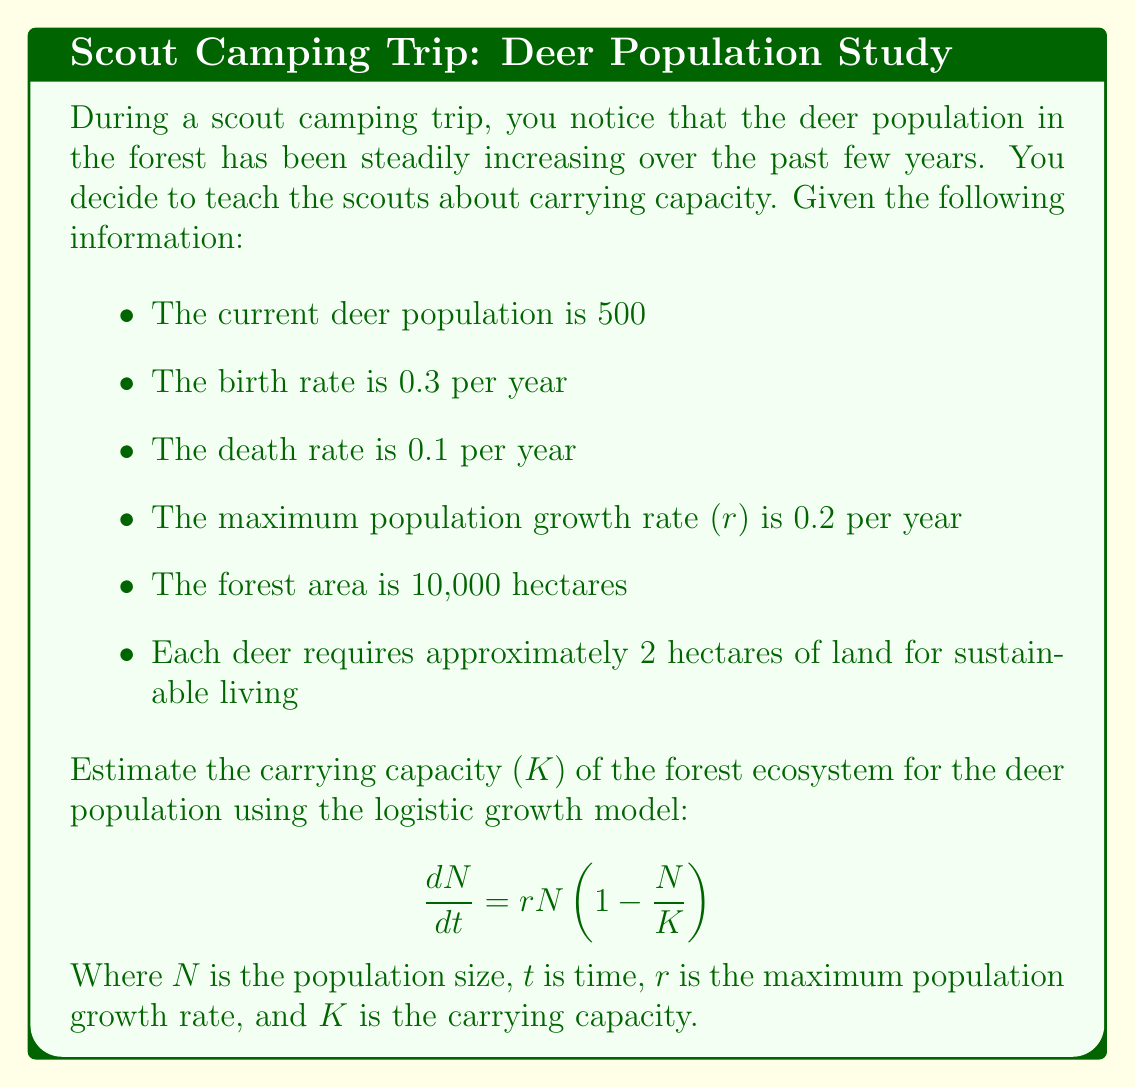Give your solution to this math problem. To estimate the carrying capacity of the forest ecosystem for the deer population, we'll follow these steps:

1. First, let's consider the given information:
   - Current deer population (N) = 500
   - Birth rate (b) = 0.3 per year
   - Death rate (d) = 0.1 per year
   - Maximum population growth rate (r) = 0.2 per year
   - Forest area = 10,000 hectares
   - Each deer requires 2 hectares

2. We can verify the maximum population growth rate:
   $r = b - d = 0.3 - 0.1 = 0.2$ per year, which matches the given value.

3. To estimate the carrying capacity, we can use two approaches:

   a) Based on the available land:
      $K = \frac{\text{Total forest area}}{\text{Area required per deer}} = \frac{10,000 \text{ hectares}}{2 \text{ hectares/deer}} = 5,000 \text{ deer}$

   b) Using the logistic growth model:
      At equilibrium, when the population reaches carrying capacity, $\frac{dN}{dt} = 0$

      So, $0 = rN(1 - \frac{N}{K})$

      This equation is satisfied when $N = K$ or $N = 0$. Since we're interested in the non-zero solution, $N = K$.

4. We can also use the given current population to estimate how close it is to the carrying capacity:

   $\frac{dN}{dt} = rN(1 - \frac{N}{K})$

   $\frac{1}{N}\frac{dN}{dt} = r(1 - \frac{N}{K})$

   The left side of this equation represents the per capita growth rate. We can estimate this using the birth and death rates:

   $\frac{1}{N}\frac{dN}{dt} = b - d = 0.3 - 0.1 = 0.2$

   So, $0.2 = 0.2(1 - \frac{500}{K})$

   Solving for K:
   $1 = 1 - \frac{500}{K}$
   $\frac{500}{K} = 0$

   This suggests that the current population is well below the carrying capacity, which aligns with our land-based estimate.

5. Therefore, we can conclude that the carrying capacity estimate based on available land (5,000 deer) is reasonable and consistent with the logistic growth model.
Answer: The estimated carrying capacity (K) of the forest ecosystem for the deer population is approximately 5,000 deer. 